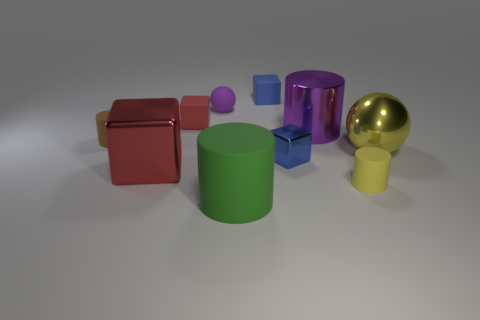There is a small metal thing; is its shape the same as the large metal thing that is left of the matte ball?
Your response must be concise. Yes. Are there fewer tiny matte cylinders that are to the left of the big yellow metal ball than rubber things that are in front of the small purple thing?
Your response must be concise. Yes. Does the yellow matte object have the same shape as the yellow metal thing?
Make the answer very short. No. What size is the blue rubber block?
Give a very brief answer. Small. What color is the block that is both in front of the brown rubber cylinder and to the right of the small purple object?
Provide a succinct answer. Blue. Are there more tiny things than small blue rubber things?
Provide a short and direct response. Yes. How many things are either red objects or big metallic things to the right of the purple cylinder?
Your response must be concise. 3. Do the yellow cylinder and the purple ball have the same size?
Provide a succinct answer. Yes. Are there any blue cubes in front of the large yellow ball?
Make the answer very short. Yes. There is a cylinder that is both left of the small metallic thing and on the right side of the big red metallic block; what size is it?
Provide a succinct answer. Large. 